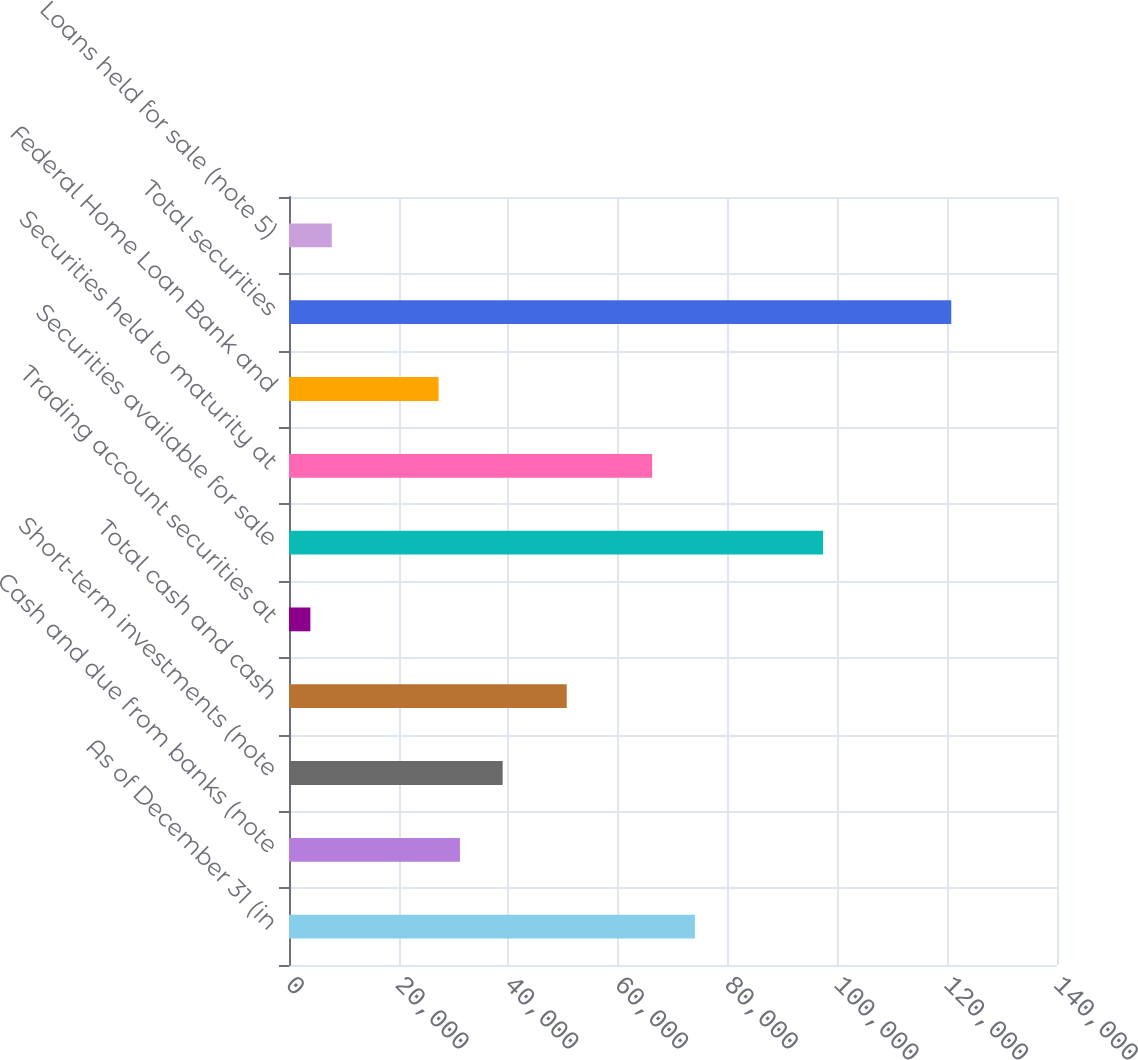Convert chart. <chart><loc_0><loc_0><loc_500><loc_500><bar_chart><fcel>As of December 31 (in<fcel>Cash and due from banks (note<fcel>Short-term investments (note<fcel>Total cash and cash<fcel>Trading account securities at<fcel>Securities available for sale<fcel>Securities held to maturity at<fcel>Federal Home Loan Bank and<fcel>Total securities<fcel>Loans held for sale (note 5)<nl><fcel>73995.2<fcel>31158.1<fcel>38946.7<fcel>50629.5<fcel>3898.18<fcel>97360.9<fcel>66206.7<fcel>27263.9<fcel>120727<fcel>7792.46<nl></chart> 